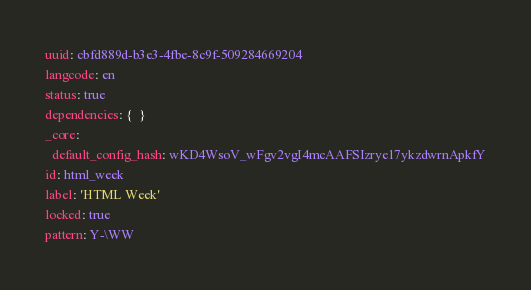<code> <loc_0><loc_0><loc_500><loc_500><_YAML_>uuid: cbfd889d-b3e3-4fbe-8c9f-509284669204
langcode: en
status: true
dependencies: {  }
_core:
  default_config_hash: wKD4WsoV_wFgv2vgI4mcAAFSIzrye17ykzdwrnApkfY
id: html_week
label: 'HTML Week'
locked: true
pattern: Y-\WW
</code> 